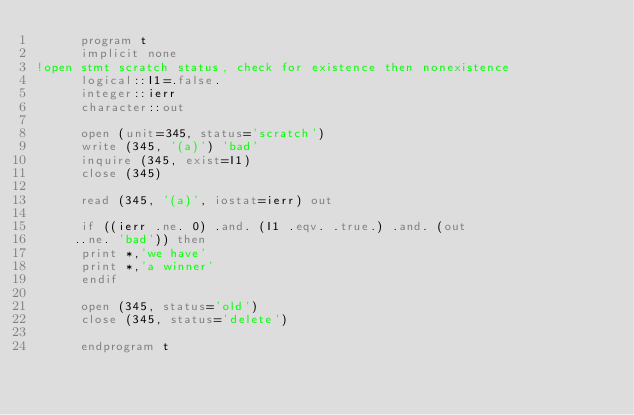Convert code to text. <code><loc_0><loc_0><loc_500><loc_500><_FORTRAN_>      program t
      implicit none
!open stmt scratch status, check for existence then nonexistence 
      logical::I1=.false.
      integer::ierr
      character::out
      
      open (unit=345, status='scratch')
      write (345, '(a)') 'bad'
      inquire (345, exist=I1)
      close (345)
      
      read (345, '(a)', iostat=ierr) out
      
      if ((ierr .ne. 0) .and. (I1 .eqv. .true.) .and. (out 
     ..ne. 'bad')) then
      print *,'we have'
      print *,'a winner'
      endif
      
      open (345, status='old')
      close (345, status='delete')
      
      endprogram t

</code> 